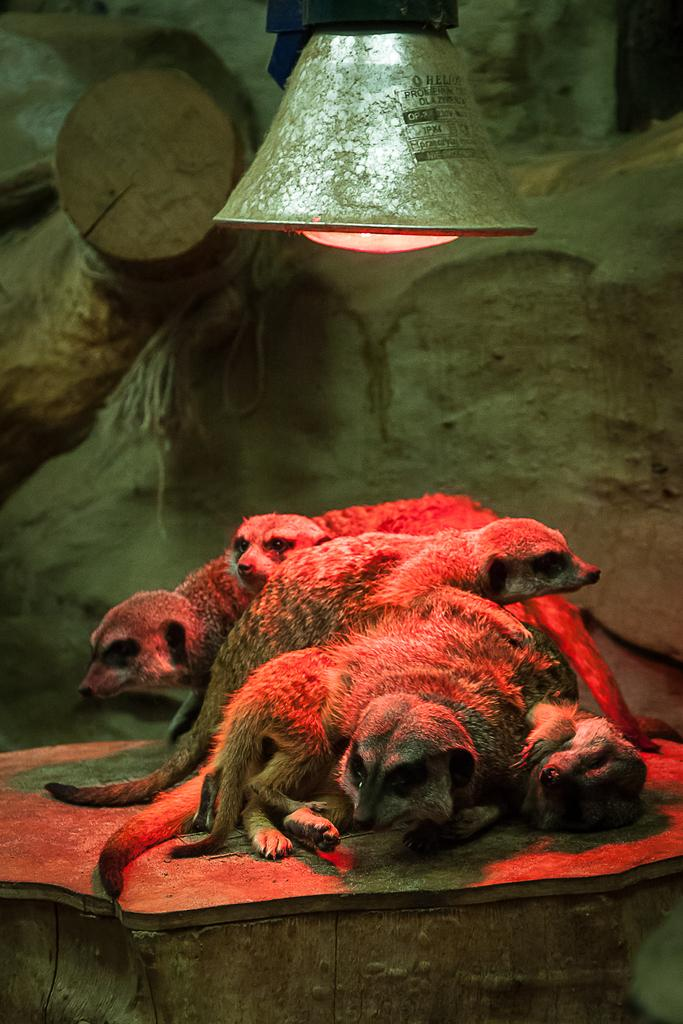What types of living organisms can be seen in the image? There are animals in the image. What geological features are present in the image? There are rocks in the image. Is there any source of illumination visible in the image? Yes, there is a light in the image. What type of boat can be seen in the image? There is no boat present in the image. Are there any shops visible in the image? There is no shop present in the image. 